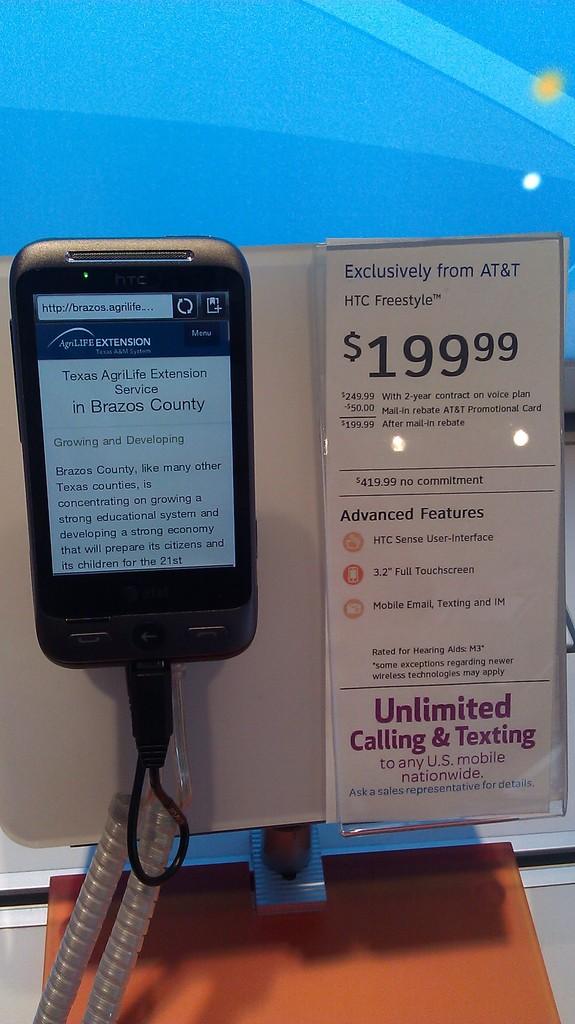How much is this phone?
Keep it short and to the point. 199.99. 